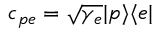Convert formula to latex. <formula><loc_0><loc_0><loc_500><loc_500>c _ { p e } = \sqrt { \gamma _ { e } } | p \rangle \langle e |</formula> 